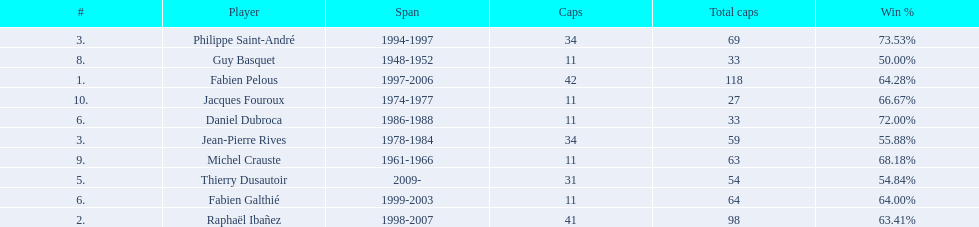How many caps did jean-pierre rives and michel crauste accrue? 122. 